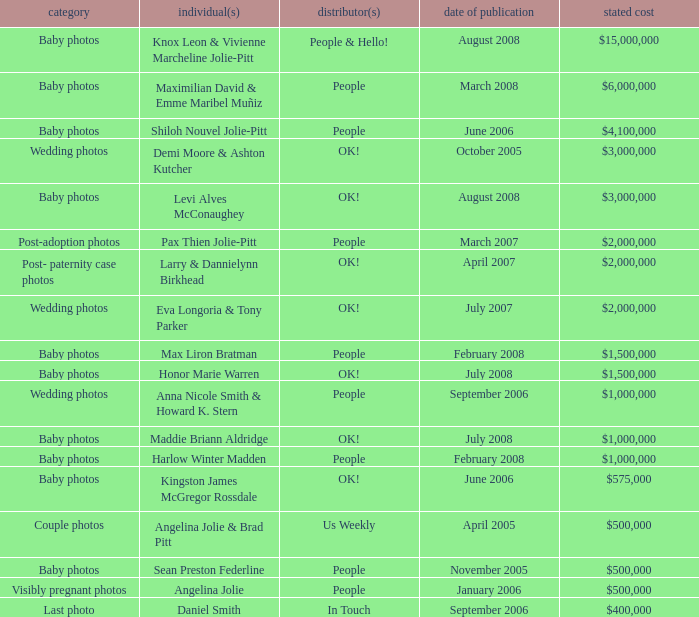What type of photos of Angelina Jolie cost $500,000? Visibly pregnant photos. Write the full table. {'header': ['category', 'individual(s)', 'distributor(s)', 'date of publication', 'stated cost'], 'rows': [['Baby photos', 'Knox Leon & Vivienne Marcheline Jolie-Pitt', 'People & Hello!', 'August 2008', '$15,000,000'], ['Baby photos', 'Maximilian David & Emme Maribel Muñiz', 'People', 'March 2008', '$6,000,000'], ['Baby photos', 'Shiloh Nouvel Jolie-Pitt', 'People', 'June 2006', '$4,100,000'], ['Wedding photos', 'Demi Moore & Ashton Kutcher', 'OK!', 'October 2005', '$3,000,000'], ['Baby photos', 'Levi Alves McConaughey', 'OK!', 'August 2008', '$3,000,000'], ['Post-adoption photos', 'Pax Thien Jolie-Pitt', 'People', 'March 2007', '$2,000,000'], ['Post- paternity case photos', 'Larry & Dannielynn Birkhead', 'OK!', 'April 2007', '$2,000,000'], ['Wedding photos', 'Eva Longoria & Tony Parker', 'OK!', 'July 2007', '$2,000,000'], ['Baby photos', 'Max Liron Bratman', 'People', 'February 2008', '$1,500,000'], ['Baby photos', 'Honor Marie Warren', 'OK!', 'July 2008', '$1,500,000'], ['Wedding photos', 'Anna Nicole Smith & Howard K. Stern', 'People', 'September 2006', '$1,000,000'], ['Baby photos', 'Maddie Briann Aldridge', 'OK!', 'July 2008', '$1,000,000'], ['Baby photos', 'Harlow Winter Madden', 'People', 'February 2008', '$1,000,000'], ['Baby photos', 'Kingston James McGregor Rossdale', 'OK!', 'June 2006', '$575,000'], ['Couple photos', 'Angelina Jolie & Brad Pitt', 'Us Weekly', 'April 2005', '$500,000'], ['Baby photos', 'Sean Preston Federline', 'People', 'November 2005', '$500,000'], ['Visibly pregnant photos', 'Angelina Jolie', 'People', 'January 2006', '$500,000'], ['Last photo', 'Daniel Smith', 'In Touch', 'September 2006', '$400,000']]} 